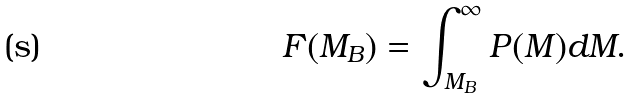Convert formula to latex. <formula><loc_0><loc_0><loc_500><loc_500>F ( M _ { B } ) = \int _ { M _ { B } } ^ { \infty } P ( M ) d M .</formula> 